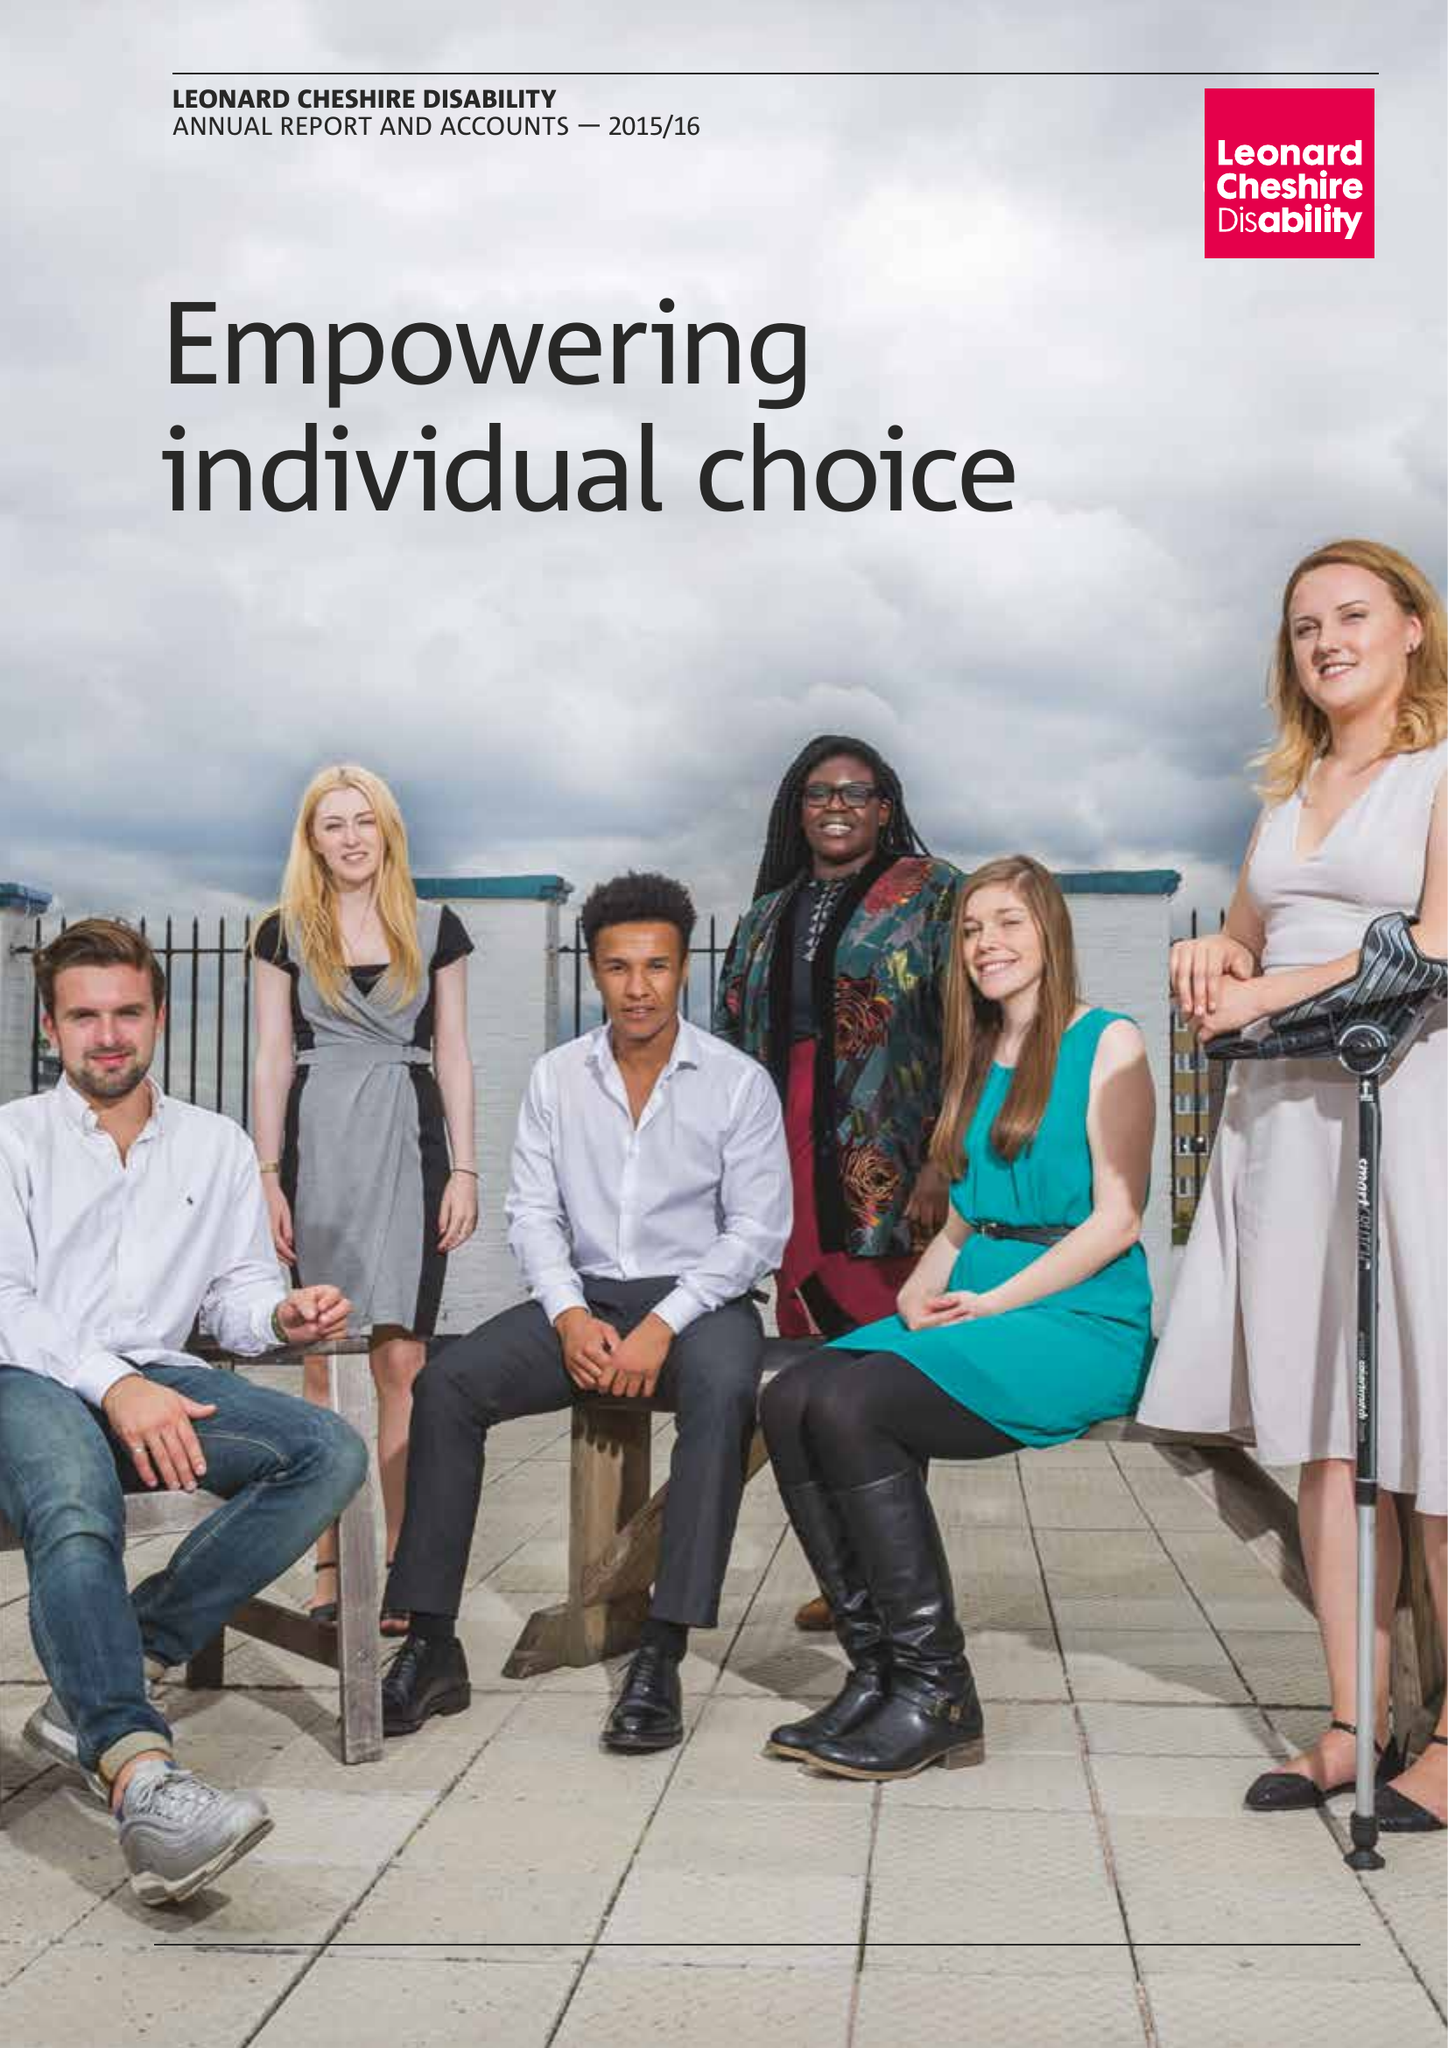What is the value for the charity_number?
Answer the question using a single word or phrase. 218186 